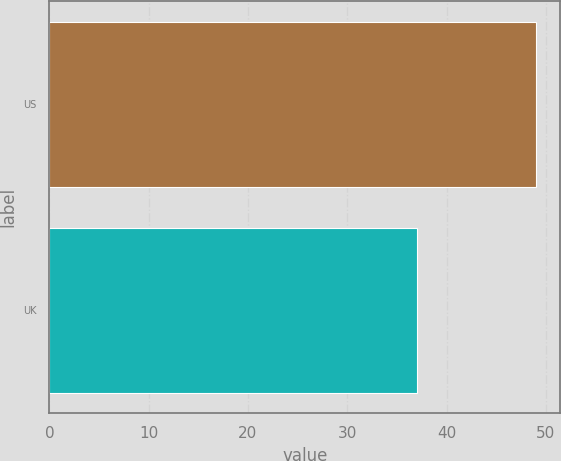Convert chart to OTSL. <chart><loc_0><loc_0><loc_500><loc_500><bar_chart><fcel>US<fcel>UK<nl><fcel>49<fcel>37<nl></chart> 